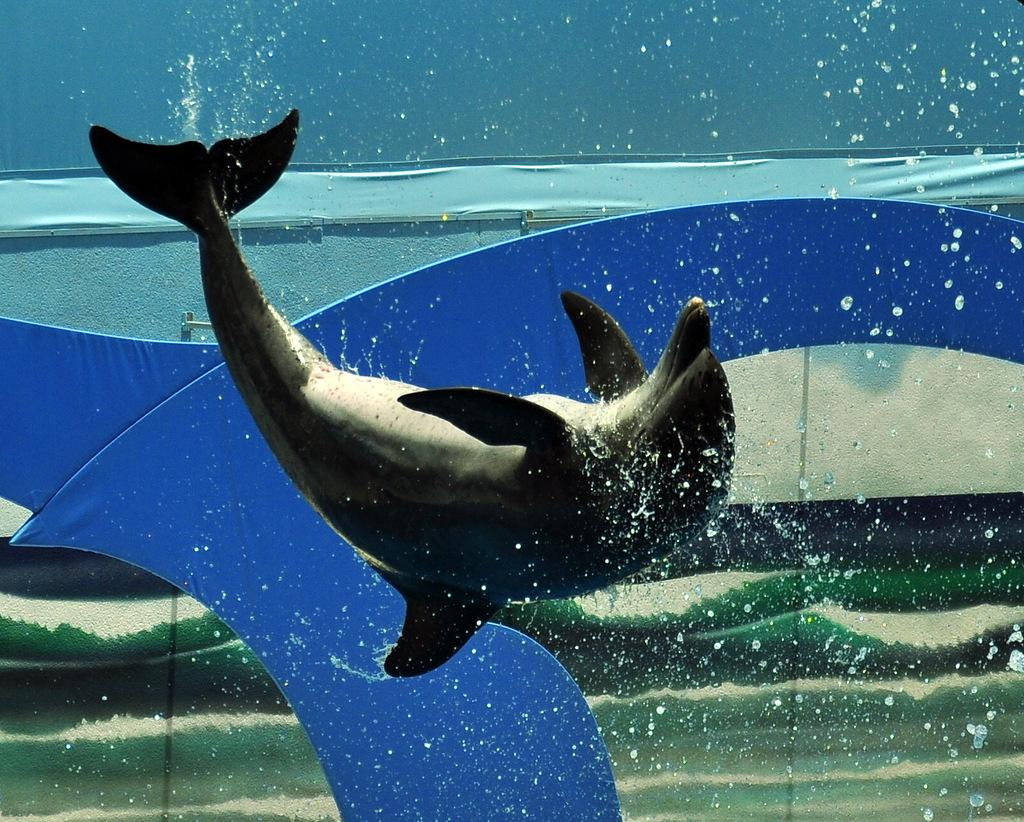What animal is featured in the image? There is a dolphin in the image. What is the dolphin's environment in the image? The dolphin appears to be in water. Can you describe the style or nature of the image? The image may be an artistic representation. How many mailboxes are visible in the image? There are no mailboxes present in the image; it features a dolphin in water. 